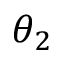Convert formula to latex. <formula><loc_0><loc_0><loc_500><loc_500>\theta _ { 2 }</formula> 